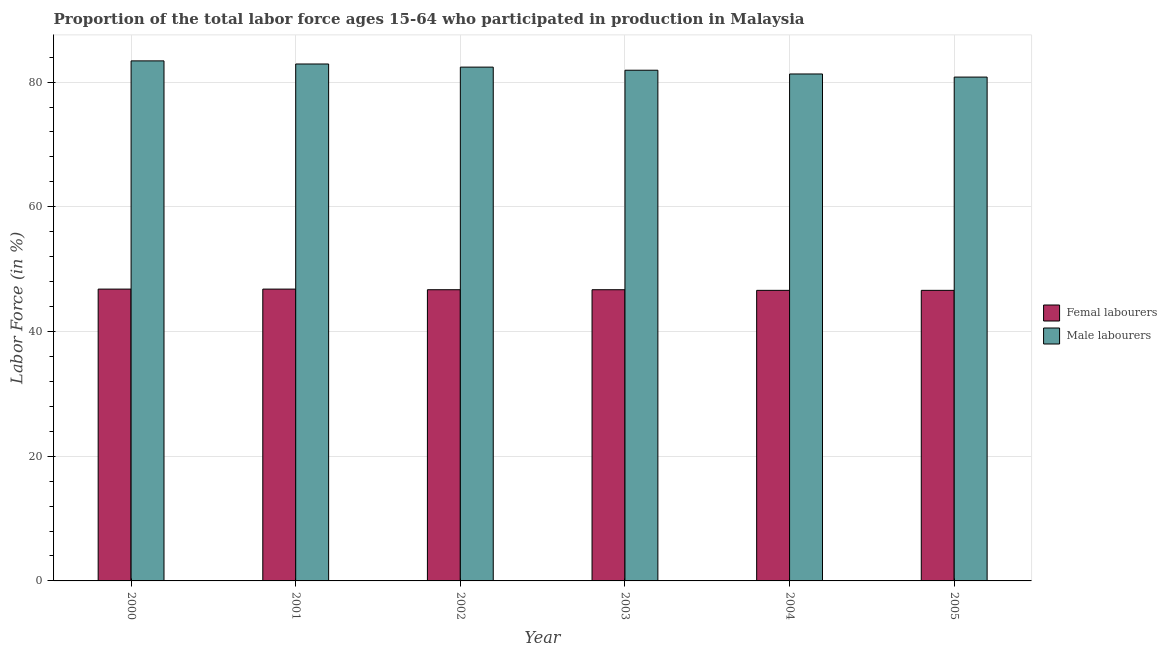How many groups of bars are there?
Give a very brief answer. 6. How many bars are there on the 1st tick from the left?
Your response must be concise. 2. In how many cases, is the number of bars for a given year not equal to the number of legend labels?
Your response must be concise. 0. What is the percentage of female labor force in 2005?
Your answer should be very brief. 46.6. Across all years, what is the maximum percentage of male labour force?
Your response must be concise. 83.4. Across all years, what is the minimum percentage of female labor force?
Give a very brief answer. 46.6. In which year was the percentage of male labour force maximum?
Give a very brief answer. 2000. What is the total percentage of female labor force in the graph?
Keep it short and to the point. 280.2. What is the difference between the percentage of male labour force in 2004 and that in 2005?
Your answer should be compact. 0.5. What is the difference between the percentage of female labor force in 2003 and the percentage of male labour force in 2004?
Your answer should be very brief. 0.1. What is the average percentage of male labour force per year?
Ensure brevity in your answer.  82.12. In the year 2005, what is the difference between the percentage of female labor force and percentage of male labour force?
Your response must be concise. 0. In how many years, is the percentage of female labor force greater than 24 %?
Ensure brevity in your answer.  6. What is the ratio of the percentage of female labor force in 2002 to that in 2004?
Provide a succinct answer. 1. What is the difference between the highest and the lowest percentage of male labour force?
Your answer should be very brief. 2.6. Is the sum of the percentage of female labor force in 2002 and 2005 greater than the maximum percentage of male labour force across all years?
Provide a succinct answer. Yes. What does the 1st bar from the left in 2005 represents?
Keep it short and to the point. Femal labourers. What does the 2nd bar from the right in 2001 represents?
Provide a short and direct response. Femal labourers. Are all the bars in the graph horizontal?
Your answer should be very brief. No. What is the difference between two consecutive major ticks on the Y-axis?
Provide a short and direct response. 20. Are the values on the major ticks of Y-axis written in scientific E-notation?
Keep it short and to the point. No. Where does the legend appear in the graph?
Ensure brevity in your answer.  Center right. How are the legend labels stacked?
Keep it short and to the point. Vertical. What is the title of the graph?
Keep it short and to the point. Proportion of the total labor force ages 15-64 who participated in production in Malaysia. Does "From World Bank" appear as one of the legend labels in the graph?
Give a very brief answer. No. What is the Labor Force (in %) of Femal labourers in 2000?
Offer a terse response. 46.8. What is the Labor Force (in %) in Male labourers in 2000?
Offer a very short reply. 83.4. What is the Labor Force (in %) in Femal labourers in 2001?
Provide a succinct answer. 46.8. What is the Labor Force (in %) in Male labourers in 2001?
Your response must be concise. 82.9. What is the Labor Force (in %) in Femal labourers in 2002?
Provide a succinct answer. 46.7. What is the Labor Force (in %) in Male labourers in 2002?
Offer a terse response. 82.4. What is the Labor Force (in %) in Femal labourers in 2003?
Give a very brief answer. 46.7. What is the Labor Force (in %) in Male labourers in 2003?
Your response must be concise. 81.9. What is the Labor Force (in %) of Femal labourers in 2004?
Provide a short and direct response. 46.6. What is the Labor Force (in %) of Male labourers in 2004?
Offer a very short reply. 81.3. What is the Labor Force (in %) in Femal labourers in 2005?
Keep it short and to the point. 46.6. What is the Labor Force (in %) in Male labourers in 2005?
Keep it short and to the point. 80.8. Across all years, what is the maximum Labor Force (in %) in Femal labourers?
Ensure brevity in your answer.  46.8. Across all years, what is the maximum Labor Force (in %) in Male labourers?
Ensure brevity in your answer.  83.4. Across all years, what is the minimum Labor Force (in %) of Femal labourers?
Keep it short and to the point. 46.6. Across all years, what is the minimum Labor Force (in %) of Male labourers?
Your answer should be compact. 80.8. What is the total Labor Force (in %) in Femal labourers in the graph?
Your response must be concise. 280.2. What is the total Labor Force (in %) in Male labourers in the graph?
Your response must be concise. 492.7. What is the difference between the Labor Force (in %) in Male labourers in 2000 and that in 2002?
Provide a short and direct response. 1. What is the difference between the Labor Force (in %) of Femal labourers in 2000 and that in 2003?
Your answer should be very brief. 0.1. What is the difference between the Labor Force (in %) in Male labourers in 2000 and that in 2003?
Your response must be concise. 1.5. What is the difference between the Labor Force (in %) of Femal labourers in 2001 and that in 2002?
Make the answer very short. 0.1. What is the difference between the Labor Force (in %) in Male labourers in 2001 and that in 2003?
Your response must be concise. 1. What is the difference between the Labor Force (in %) of Femal labourers in 2001 and that in 2004?
Offer a terse response. 0.2. What is the difference between the Labor Force (in %) in Male labourers in 2001 and that in 2005?
Ensure brevity in your answer.  2.1. What is the difference between the Labor Force (in %) of Femal labourers in 2002 and that in 2004?
Your response must be concise. 0.1. What is the difference between the Labor Force (in %) of Male labourers in 2002 and that in 2004?
Your response must be concise. 1.1. What is the difference between the Labor Force (in %) in Femal labourers in 2002 and that in 2005?
Ensure brevity in your answer.  0.1. What is the difference between the Labor Force (in %) of Male labourers in 2002 and that in 2005?
Your response must be concise. 1.6. What is the difference between the Labor Force (in %) in Femal labourers in 2003 and that in 2005?
Your response must be concise. 0.1. What is the difference between the Labor Force (in %) in Femal labourers in 2000 and the Labor Force (in %) in Male labourers in 2001?
Keep it short and to the point. -36.1. What is the difference between the Labor Force (in %) of Femal labourers in 2000 and the Labor Force (in %) of Male labourers in 2002?
Your response must be concise. -35.6. What is the difference between the Labor Force (in %) in Femal labourers in 2000 and the Labor Force (in %) in Male labourers in 2003?
Your response must be concise. -35.1. What is the difference between the Labor Force (in %) of Femal labourers in 2000 and the Labor Force (in %) of Male labourers in 2004?
Provide a short and direct response. -34.5. What is the difference between the Labor Force (in %) in Femal labourers in 2000 and the Labor Force (in %) in Male labourers in 2005?
Your answer should be compact. -34. What is the difference between the Labor Force (in %) in Femal labourers in 2001 and the Labor Force (in %) in Male labourers in 2002?
Your response must be concise. -35.6. What is the difference between the Labor Force (in %) in Femal labourers in 2001 and the Labor Force (in %) in Male labourers in 2003?
Make the answer very short. -35.1. What is the difference between the Labor Force (in %) in Femal labourers in 2001 and the Labor Force (in %) in Male labourers in 2004?
Your response must be concise. -34.5. What is the difference between the Labor Force (in %) of Femal labourers in 2001 and the Labor Force (in %) of Male labourers in 2005?
Ensure brevity in your answer.  -34. What is the difference between the Labor Force (in %) in Femal labourers in 2002 and the Labor Force (in %) in Male labourers in 2003?
Provide a succinct answer. -35.2. What is the difference between the Labor Force (in %) of Femal labourers in 2002 and the Labor Force (in %) of Male labourers in 2004?
Give a very brief answer. -34.6. What is the difference between the Labor Force (in %) of Femal labourers in 2002 and the Labor Force (in %) of Male labourers in 2005?
Provide a short and direct response. -34.1. What is the difference between the Labor Force (in %) of Femal labourers in 2003 and the Labor Force (in %) of Male labourers in 2004?
Provide a succinct answer. -34.6. What is the difference between the Labor Force (in %) in Femal labourers in 2003 and the Labor Force (in %) in Male labourers in 2005?
Give a very brief answer. -34.1. What is the difference between the Labor Force (in %) in Femal labourers in 2004 and the Labor Force (in %) in Male labourers in 2005?
Provide a short and direct response. -34.2. What is the average Labor Force (in %) in Femal labourers per year?
Give a very brief answer. 46.7. What is the average Labor Force (in %) in Male labourers per year?
Your answer should be compact. 82.12. In the year 2000, what is the difference between the Labor Force (in %) in Femal labourers and Labor Force (in %) in Male labourers?
Your answer should be very brief. -36.6. In the year 2001, what is the difference between the Labor Force (in %) of Femal labourers and Labor Force (in %) of Male labourers?
Your answer should be very brief. -36.1. In the year 2002, what is the difference between the Labor Force (in %) in Femal labourers and Labor Force (in %) in Male labourers?
Your answer should be very brief. -35.7. In the year 2003, what is the difference between the Labor Force (in %) of Femal labourers and Labor Force (in %) of Male labourers?
Ensure brevity in your answer.  -35.2. In the year 2004, what is the difference between the Labor Force (in %) in Femal labourers and Labor Force (in %) in Male labourers?
Provide a succinct answer. -34.7. In the year 2005, what is the difference between the Labor Force (in %) of Femal labourers and Labor Force (in %) of Male labourers?
Keep it short and to the point. -34.2. What is the ratio of the Labor Force (in %) in Male labourers in 2000 to that in 2001?
Provide a short and direct response. 1.01. What is the ratio of the Labor Force (in %) in Male labourers in 2000 to that in 2002?
Provide a succinct answer. 1.01. What is the ratio of the Labor Force (in %) of Male labourers in 2000 to that in 2003?
Your response must be concise. 1.02. What is the ratio of the Labor Force (in %) of Femal labourers in 2000 to that in 2004?
Ensure brevity in your answer.  1. What is the ratio of the Labor Force (in %) in Male labourers in 2000 to that in 2004?
Your response must be concise. 1.03. What is the ratio of the Labor Force (in %) in Male labourers in 2000 to that in 2005?
Offer a terse response. 1.03. What is the ratio of the Labor Force (in %) in Male labourers in 2001 to that in 2002?
Offer a terse response. 1.01. What is the ratio of the Labor Force (in %) in Femal labourers in 2001 to that in 2003?
Offer a terse response. 1. What is the ratio of the Labor Force (in %) of Male labourers in 2001 to that in 2003?
Offer a very short reply. 1.01. What is the ratio of the Labor Force (in %) of Femal labourers in 2001 to that in 2004?
Provide a short and direct response. 1. What is the ratio of the Labor Force (in %) of Male labourers in 2001 to that in 2004?
Your response must be concise. 1.02. What is the ratio of the Labor Force (in %) in Femal labourers in 2001 to that in 2005?
Give a very brief answer. 1. What is the ratio of the Labor Force (in %) of Male labourers in 2001 to that in 2005?
Keep it short and to the point. 1.03. What is the ratio of the Labor Force (in %) in Male labourers in 2002 to that in 2004?
Your answer should be compact. 1.01. What is the ratio of the Labor Force (in %) of Male labourers in 2002 to that in 2005?
Your answer should be compact. 1.02. What is the ratio of the Labor Force (in %) in Femal labourers in 2003 to that in 2004?
Provide a succinct answer. 1. What is the ratio of the Labor Force (in %) of Male labourers in 2003 to that in 2004?
Offer a very short reply. 1.01. What is the ratio of the Labor Force (in %) of Male labourers in 2003 to that in 2005?
Provide a succinct answer. 1.01. What is the ratio of the Labor Force (in %) in Male labourers in 2004 to that in 2005?
Ensure brevity in your answer.  1.01. What is the difference between the highest and the second highest Labor Force (in %) in Male labourers?
Provide a short and direct response. 0.5. What is the difference between the highest and the lowest Labor Force (in %) of Femal labourers?
Your answer should be compact. 0.2. 